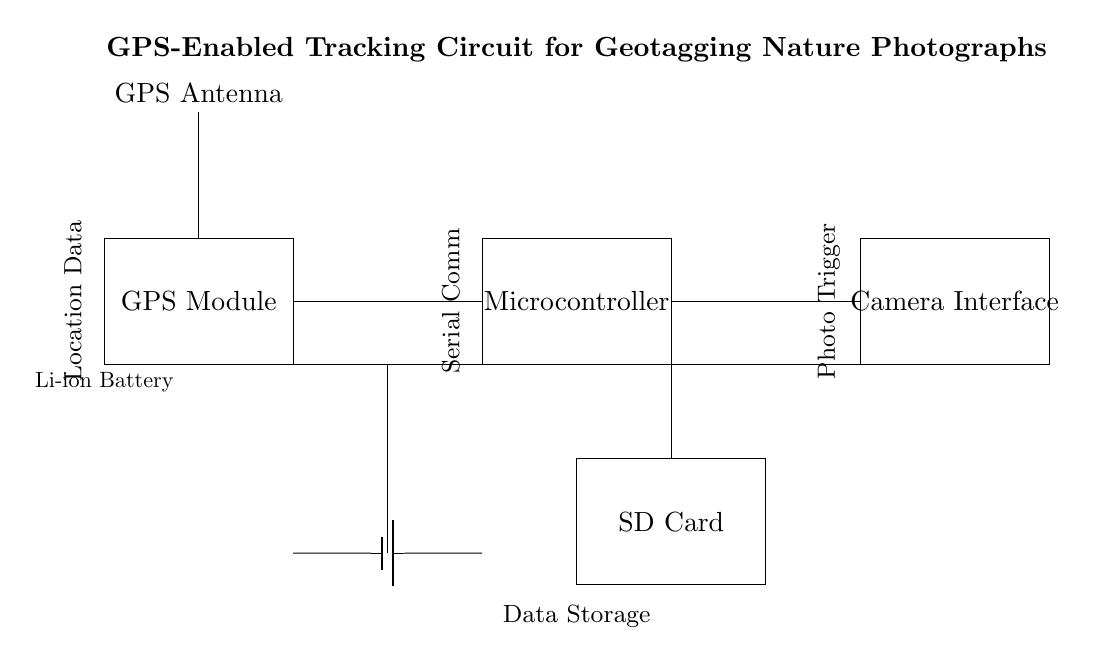What is the main component used for GPS functionality? The main component for GPS functionality is the GPS Module, which processes location data to geotag photographs.
Answer: GPS Module What type of power source is used in this circuit? The circuit uses a Li-ion battery, which is a common power source for portable devices due to its high energy density.
Answer: Li-ion Battery How many main components are connected in the circuit? There are four main components connected in the circuit: GPS Module, Microcontroller, Camera Interface, and SD Card.
Answer: Four What is the purpose of the antenna in the circuit? The purpose of the antenna is to connect to GPS signals, allowing the GPS Module to receive location data for geotagging.
Answer: GPS Antenna Which component stores the photographs taken by the camera? The component that stores the photographs taken by the camera is the SD Card, which provides data storage for images.
Answer: SD Card What type of communication is indicated between the components? The communication type indicated is serial communication, which is commonly used for transmitting data between the microcontroller and other components.
Answer: Serial Comm How does the battery connect to the other components in the circuit? The battery connects to the GPS Module, Microcontroller, and Camera Interface, providing power through a series of connections to enable all components.
Answer: Power Connections 